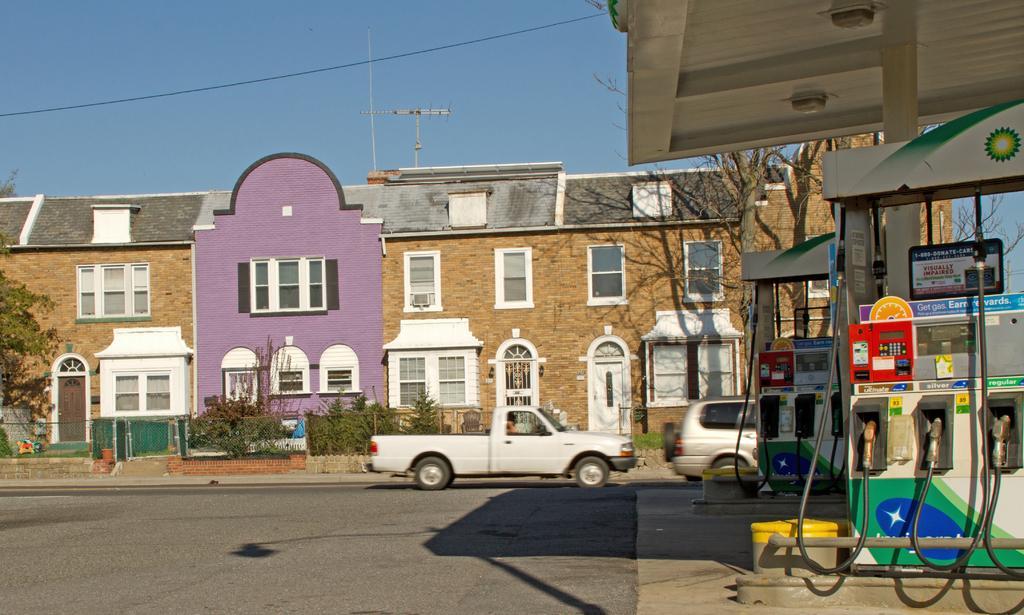Can you describe this image briefly? In this image we can see two vehicles parked on the road. On the right side of the image we can see a gas station with pipes and metal poles. In the background, we can see a building with group of windows and doors, a group of trees and sky. 